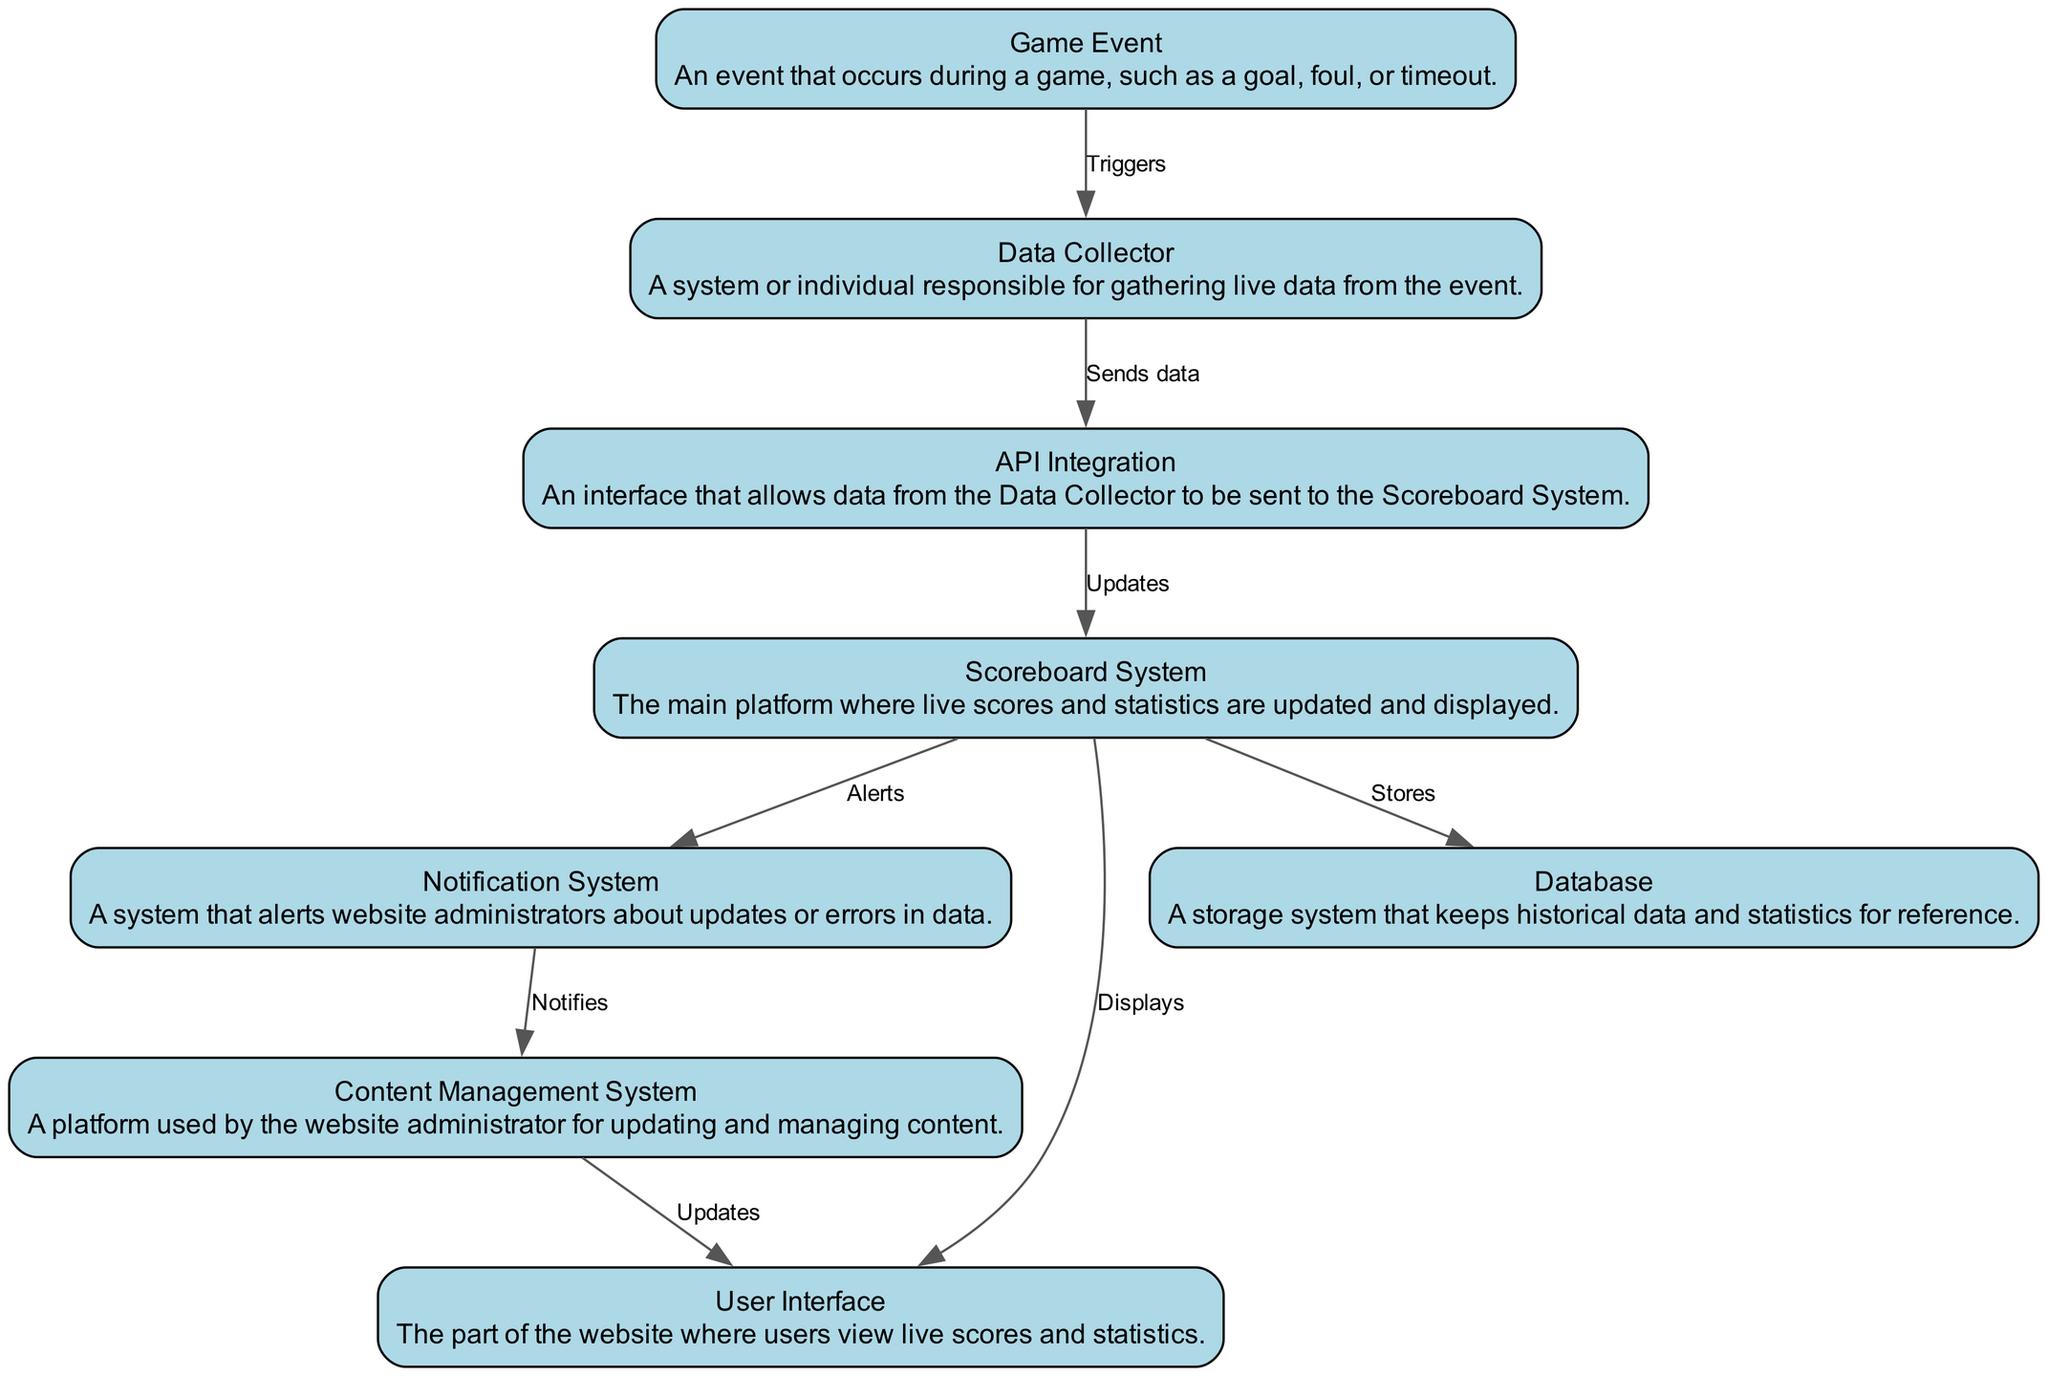What triggers the data collection process? The data collection process is triggered by a 'Game Event', which is any occurrence during the game, like a goal or foul. Hence, the trigger source is clearly defined in the diagram.
Answer: Game Event How many nodes are present in the diagram? To determine the number of nodes, we can count the unique elements depicted in the diagram. There are eight nodes representing different components in the workflow: Game Event, Data Collector, API Integration, Scoreboard System, Notification System, User Interface, Database, and Content Management System.
Answer: Eight What does the Scoreboard System do after receiving data from the API Integration? After receiving data from the API Integration, the Scoreboard System updates its information. The diagram indicates that this step directly follows the data transfer from the API.
Answer: Updates Which system receives alerts from the Scoreboard System? The diagram shows that the Scoreboard System sends alerts to the Notification System, which is responsible for notifying website administrators about updates or errors.
Answer: Notification System What are the two actions of the Scoreboard System towards the User Interface and Database? The Scoreboard System carries out two actions: it displays the updated information to the User Interface and stores data in the Database. These actions are clearly outlined in the diagram as separate outgoing edges from the Scoreboard System.
Answer: Displays and Stores How does the Notification System interact with the Content Management System? The Notification System interacts with the Content Management System by sending notifications. According to the diagram, this is an alerting action that informs the CMS about updates or errors occurring in the data flow.
Answer: Notifies What initial event starts the workflow? The workflow is initiated by the occurrence of a 'Game Event.' This serves as the foundational input for the subsequent processes depicted in the diagram.
Answer: Game Event What system is responsible for gathering live data? The system tasked with gathering live data from the game events is the Data Collector. The diagram illustrates this role as the first step in the data workflow.
Answer: Data Collector What kind of system is the User Interface? The User Interface is characterized as part of the platform where users can view the live scores and statistics. This description is directly derived from the label in the diagram.
Answer: Viewing platform 